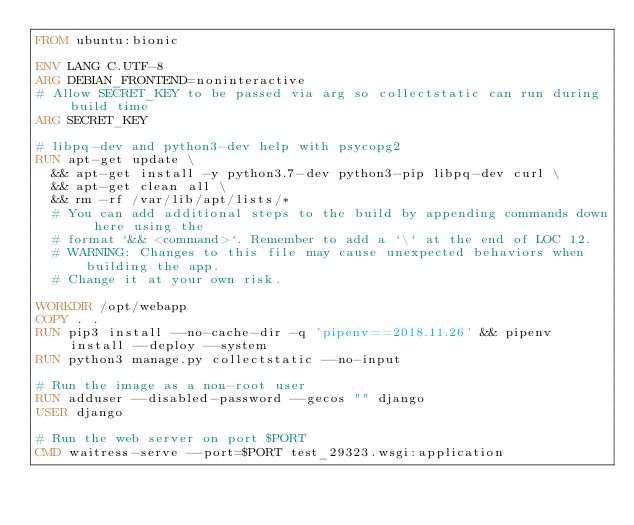<code> <loc_0><loc_0><loc_500><loc_500><_Dockerfile_>FROM ubuntu:bionic

ENV LANG C.UTF-8
ARG DEBIAN_FRONTEND=noninteractive
# Allow SECRET_KEY to be passed via arg so collectstatic can run during build time
ARG SECRET_KEY

# libpq-dev and python3-dev help with psycopg2
RUN apt-get update \
  && apt-get install -y python3.7-dev python3-pip libpq-dev curl \
  && apt-get clean all \
  && rm -rf /var/lib/apt/lists/*
  # You can add additional steps to the build by appending commands down here using the
  # format `&& <command>`. Remember to add a `\` at the end of LOC 12.
  # WARNING: Changes to this file may cause unexpected behaviors when building the app.
  # Change it at your own risk.

WORKDIR /opt/webapp
COPY . .
RUN pip3 install --no-cache-dir -q 'pipenv==2018.11.26' && pipenv install --deploy --system
RUN python3 manage.py collectstatic --no-input

# Run the image as a non-root user
RUN adduser --disabled-password --gecos "" django
USER django

# Run the web server on port $PORT
CMD waitress-serve --port=$PORT test_29323.wsgi:application
</code> 